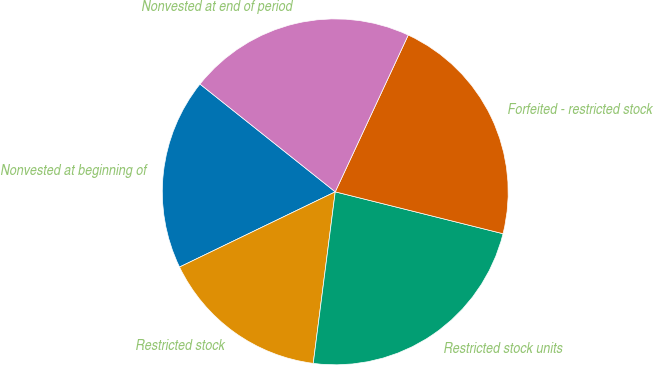Convert chart to OTSL. <chart><loc_0><loc_0><loc_500><loc_500><pie_chart><fcel>Nonvested at beginning of<fcel>Restricted stock<fcel>Restricted stock units<fcel>Forfeited - restricted stock<fcel>Nonvested at end of period<nl><fcel>17.87%<fcel>15.81%<fcel>23.14%<fcel>21.96%<fcel>21.23%<nl></chart> 